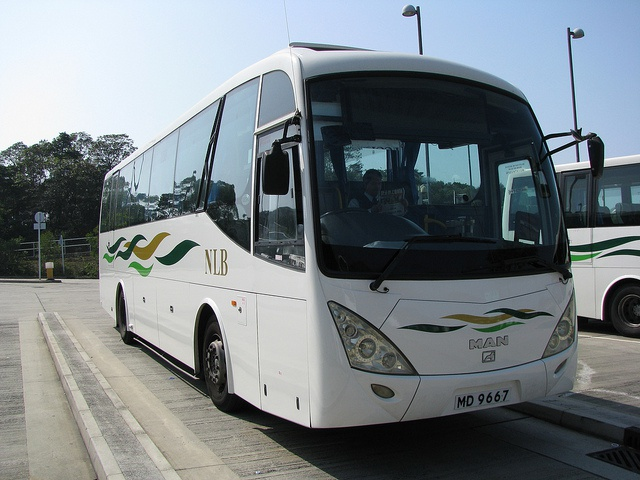Describe the objects in this image and their specific colors. I can see bus in white, black, lightgray, gray, and darkgray tones, bus in white, black, lightgray, blue, and darkgray tones, people in white, black, darkblue, and purple tones, and stop sign in white, gray, blue, and black tones in this image. 